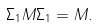<formula> <loc_0><loc_0><loc_500><loc_500>\Sigma _ { 1 } M \Sigma _ { 1 } = M .</formula> 